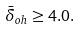Convert formula to latex. <formula><loc_0><loc_0><loc_500><loc_500>\bar { \delta } _ { o h } \geq 4 . 0 .</formula> 